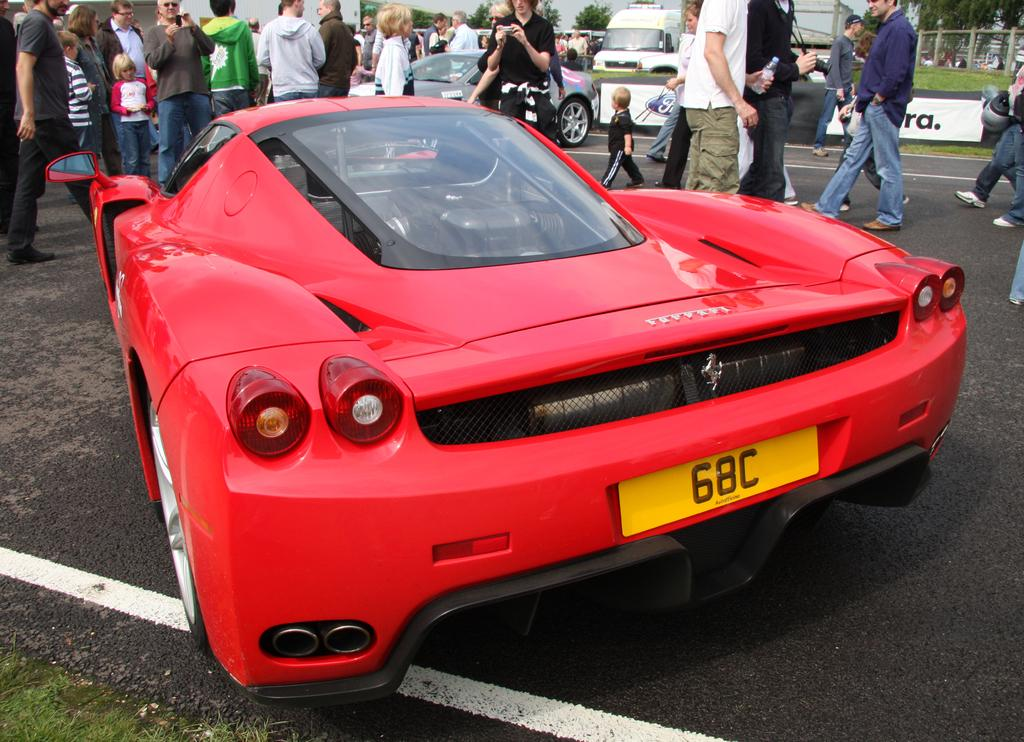What types of objects are present in the image? There are vehicles and a board with text in the image. What can be seen on the ground in the image? There is a group of people on the ground in the image. What type of terrain is visible in the image? Grass is visible in the image. What is the natural environment feature in the image? There is a group of trees in the image. What is visible in the background of the image? The sky is visible in the image. What type of jam is being spread on the foot in the image? There is no jam or foot present in the image. What activity are the people engaging in during recess in the image? The image does not depict a recess or any specific activity involving the group of people. 